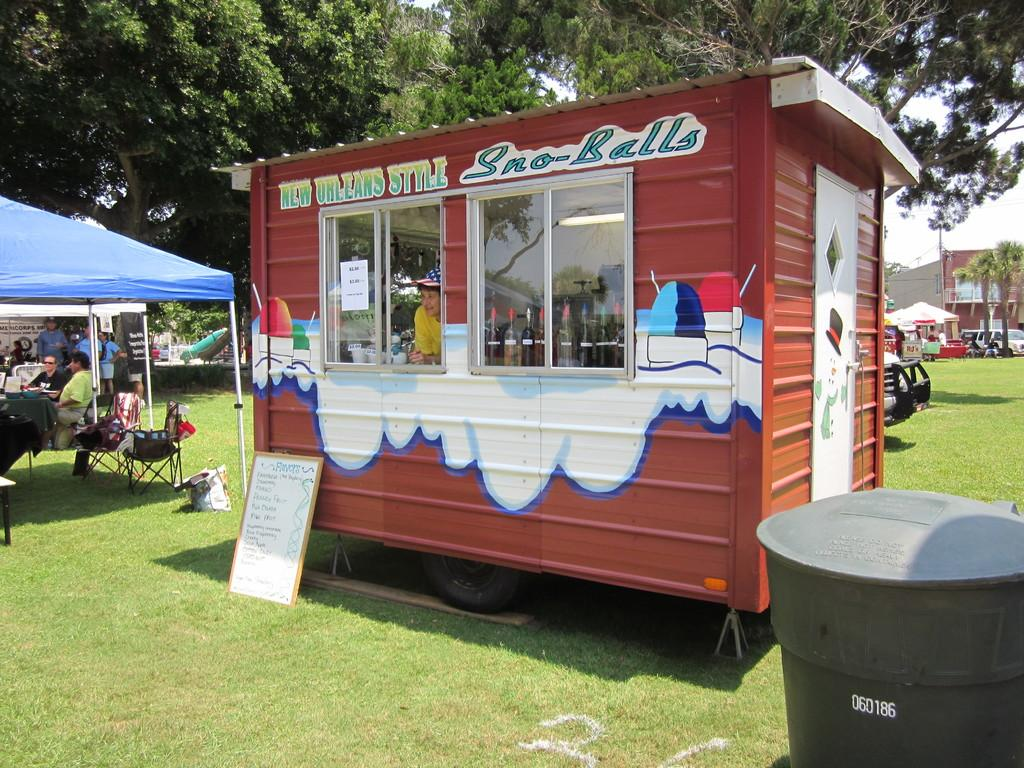<image>
Write a terse but informative summary of the picture. The sno balls at the stand are New Orleans style. 